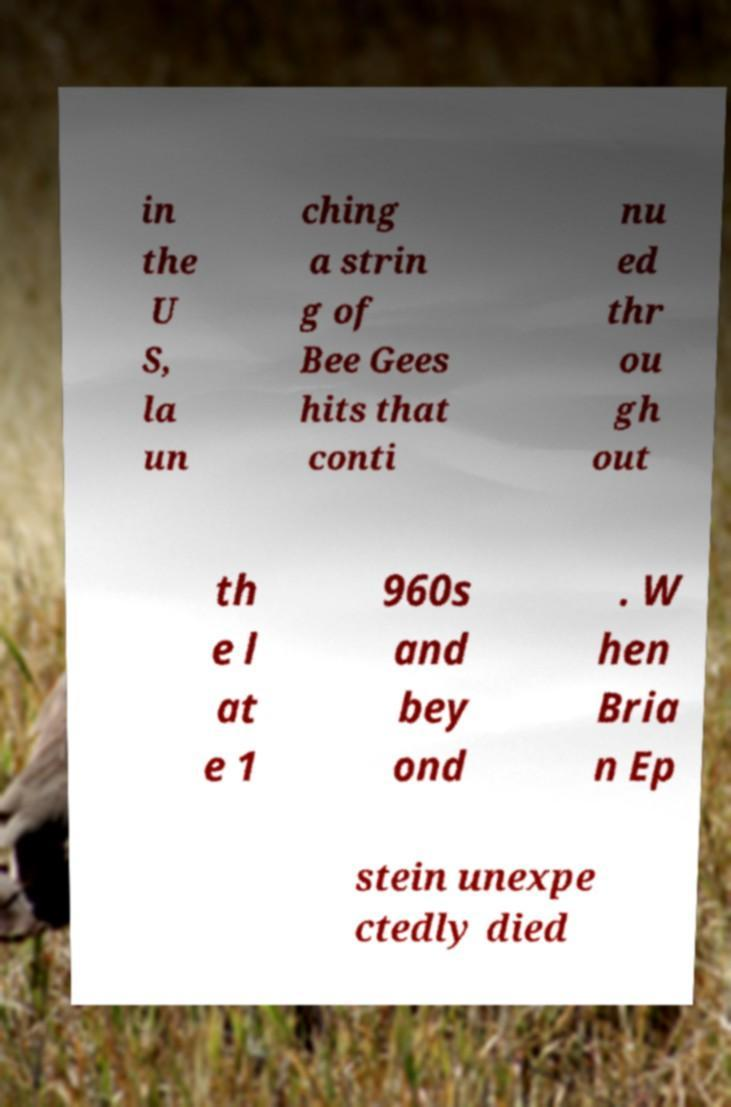I need the written content from this picture converted into text. Can you do that? in the U S, la un ching a strin g of Bee Gees hits that conti nu ed thr ou gh out th e l at e 1 960s and bey ond . W hen Bria n Ep stein unexpe ctedly died 